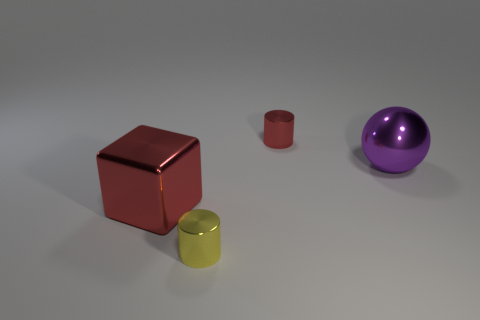Is there a red cylinder made of the same material as the purple sphere?
Ensure brevity in your answer.  Yes. There is a tiny thing that is behind the large purple sphere; is its shape the same as the purple thing?
Your response must be concise. No. There is a red thing in front of the tiny red shiny cylinder behind the big purple shiny sphere; how many small shiny cylinders are in front of it?
Keep it short and to the point. 1. Are there fewer large red metallic objects that are behind the big red shiny object than objects in front of the shiny ball?
Your answer should be very brief. Yes. The other shiny object that is the same shape as the yellow object is what color?
Keep it short and to the point. Red. The block has what size?
Provide a short and direct response. Large. How many cyan objects are the same size as the purple metal object?
Provide a short and direct response. 0. Is the material of the large thing that is on the right side of the tiny yellow shiny thing the same as the small object that is in front of the big red thing?
Keep it short and to the point. Yes. Are there more yellow rubber cubes than small yellow metal things?
Keep it short and to the point. No. Is there anything else that has the same color as the metal block?
Provide a short and direct response. Yes. 